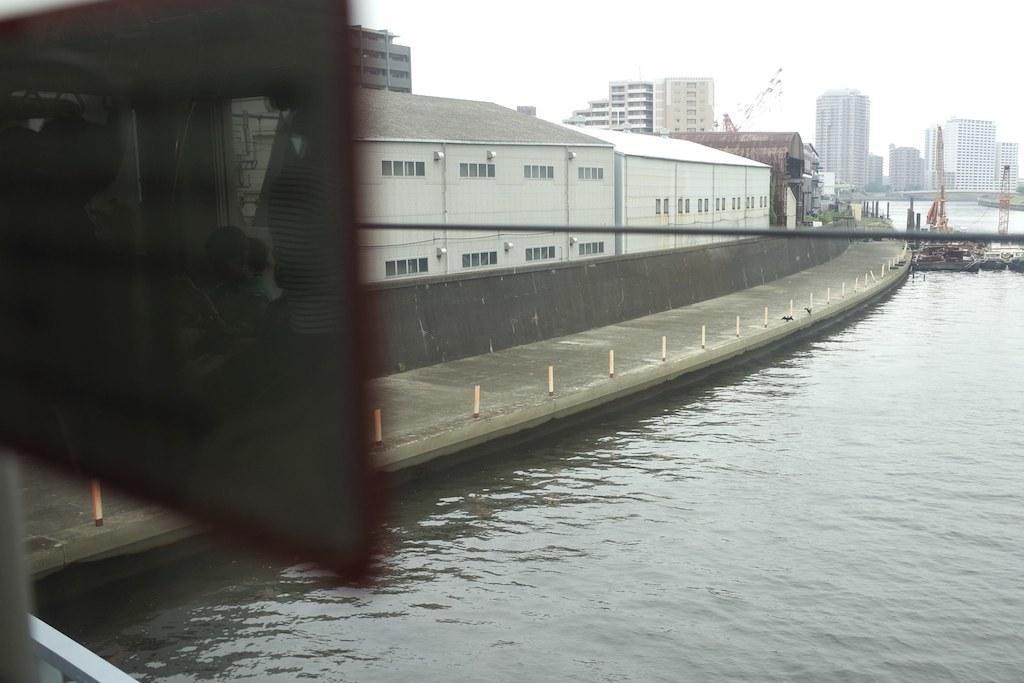Could you give a brief overview of what you see in this image? This is an outside view. At the bottom, I can see the water. On the right side there are few boats on the water. In the background there are many buildings. At the top of the image I can see the sky. On the left side there is an object which seems to be a board. 